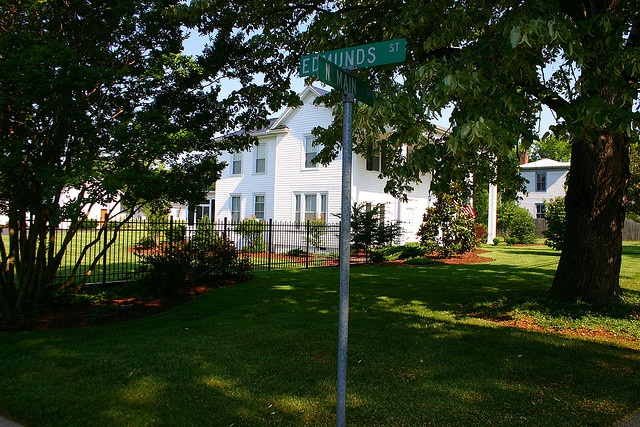Describe the objects in this image and their specific colors. I can see various objects in this image with different colors. 